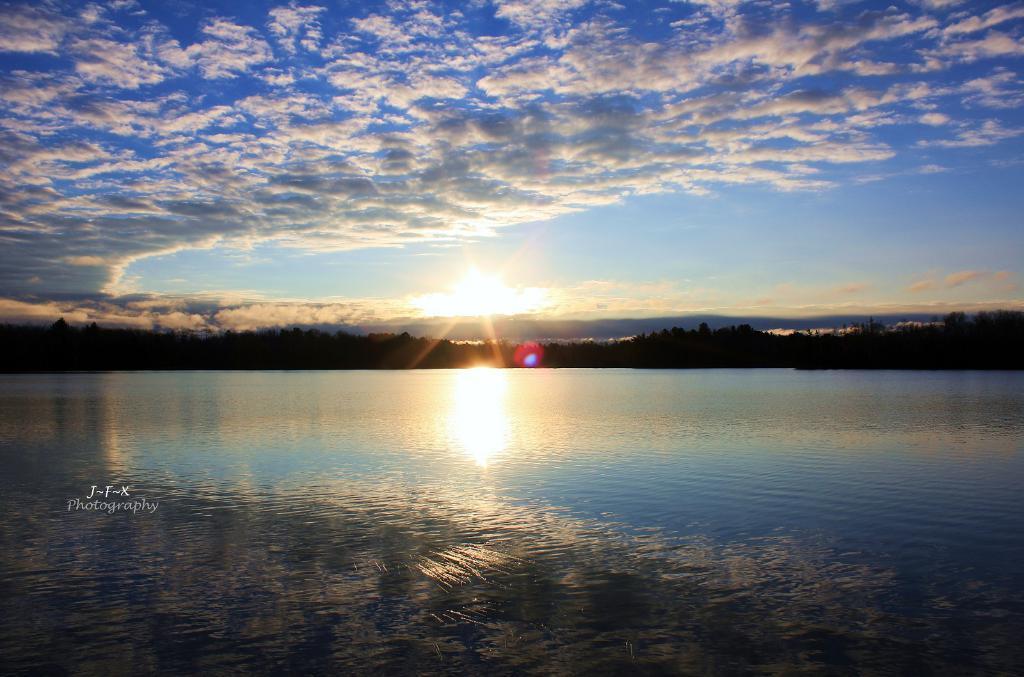In one or two sentences, can you explain what this image depicts? In this picture, I can see water, trees and I can see a blue cloudy sky and I can see sunlight and text at the bottom left corner of the picture. 